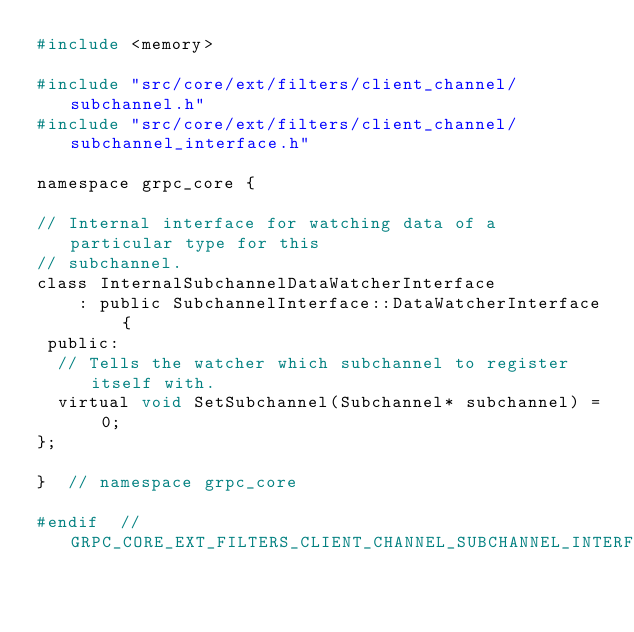Convert code to text. <code><loc_0><loc_0><loc_500><loc_500><_C_>#include <memory>

#include "src/core/ext/filters/client_channel/subchannel.h"
#include "src/core/ext/filters/client_channel/subchannel_interface.h"

namespace grpc_core {

// Internal interface for watching data of a particular type for this
// subchannel.
class InternalSubchannelDataWatcherInterface
    : public SubchannelInterface::DataWatcherInterface {
 public:
  // Tells the watcher which subchannel to register itself with.
  virtual void SetSubchannel(Subchannel* subchannel) = 0;
};

}  // namespace grpc_core

#endif  // GRPC_CORE_EXT_FILTERS_CLIENT_CHANNEL_SUBCHANNEL_INTERFACE_INTERNAL_H
</code> 